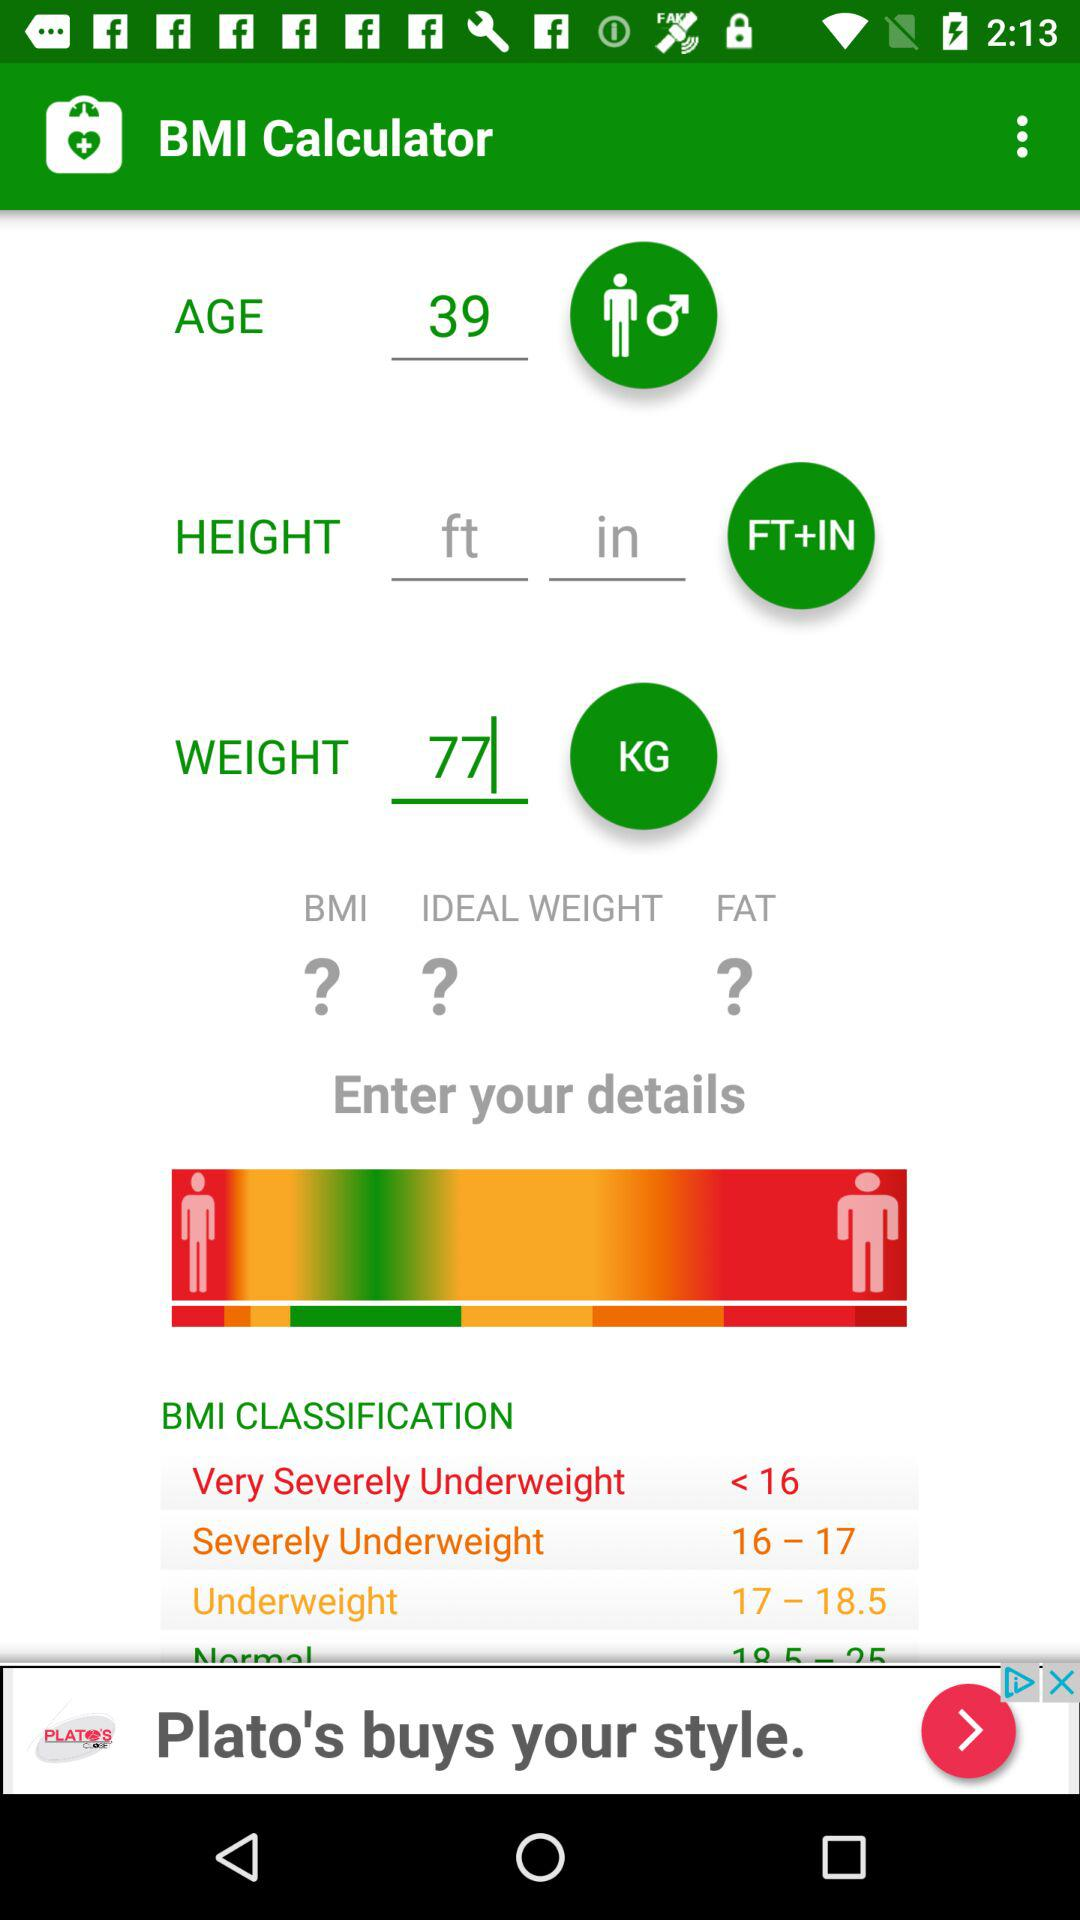What is the application name? The application name is "BMI Calculator". 